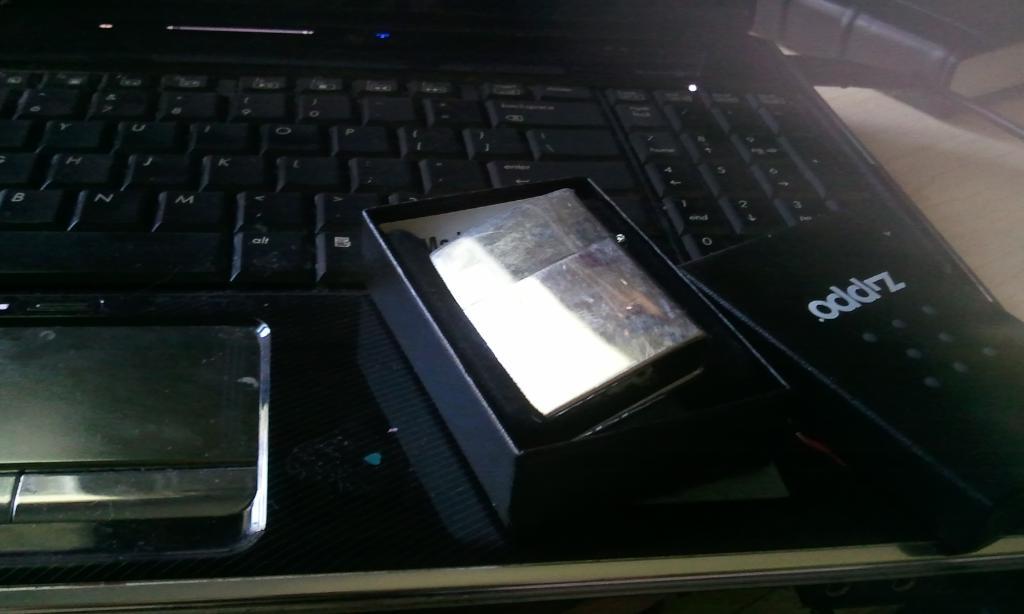What is the brand of lighter?
Your response must be concise. Zippo. What brand is the black product?
Keep it short and to the point. Zippo. 